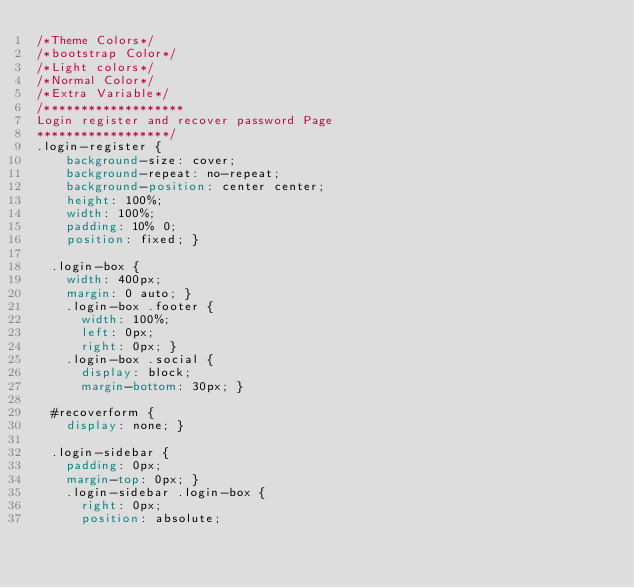Convert code to text. <code><loc_0><loc_0><loc_500><loc_500><_CSS_>/*Theme Colors*/
/*bootstrap Color*/
/*Light colors*/
/*Normal Color*/
/*Extra Variable*/
/*******************
Login register and recover password Page
******************/
.login-register {
    background-size: cover;
    background-repeat: no-repeat;
    background-position: center center;
    height: 100%;
    width: 100%;
    padding: 10% 0;
    position: fixed; }
  
  .login-box {
    width: 400px;
    margin: 0 auto; }
    .login-box .footer {
      width: 100%;
      left: 0px;
      right: 0px; }
    .login-box .social {
      display: block;
      margin-bottom: 30px; }
  
  #recoverform {
    display: none; }
  
  .login-sidebar {
    padding: 0px;
    margin-top: 0px; }
    .login-sidebar .login-box {
      right: 0px;
      position: absolute;</code> 